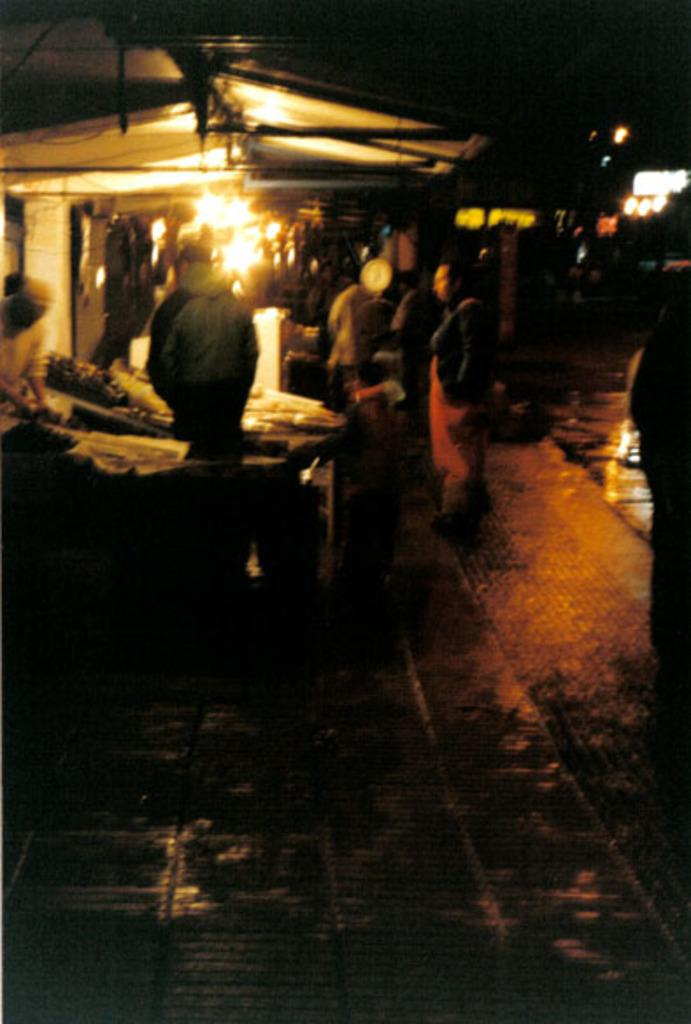What is the main subject of the image? The image depicts a market in the foreground. Can you describe the people in the image? People are standing on the side path in the image. How would you describe the lighting conditions in the image? The scene takes place in a dark setting, but there are lights visible in the image. What type of oven can be seen in the image? There is no oven present in the image. How does the stomach of the person on the side path feel in the image? We cannot determine the feelings or sensations of the people in the image based on the provided facts. 